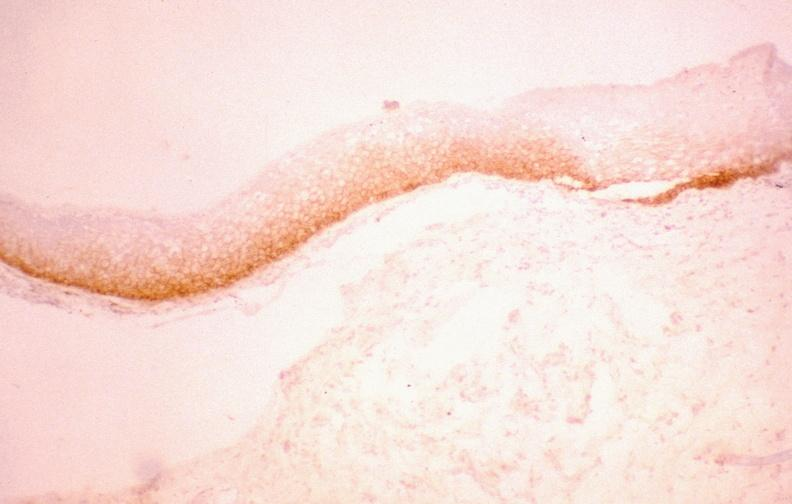where is this from?
Answer the question using a single word or phrase. Gastrointestinal system 